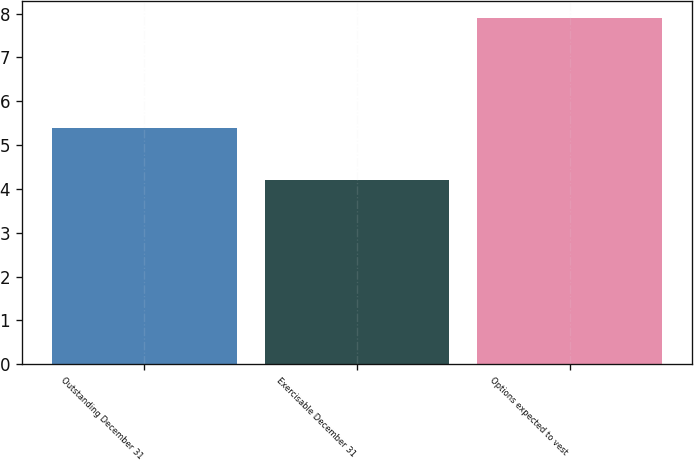Convert chart. <chart><loc_0><loc_0><loc_500><loc_500><bar_chart><fcel>Outstanding December 31<fcel>Exercisable December 31<fcel>Options expected to vest<nl><fcel>5.4<fcel>4.2<fcel>7.9<nl></chart> 